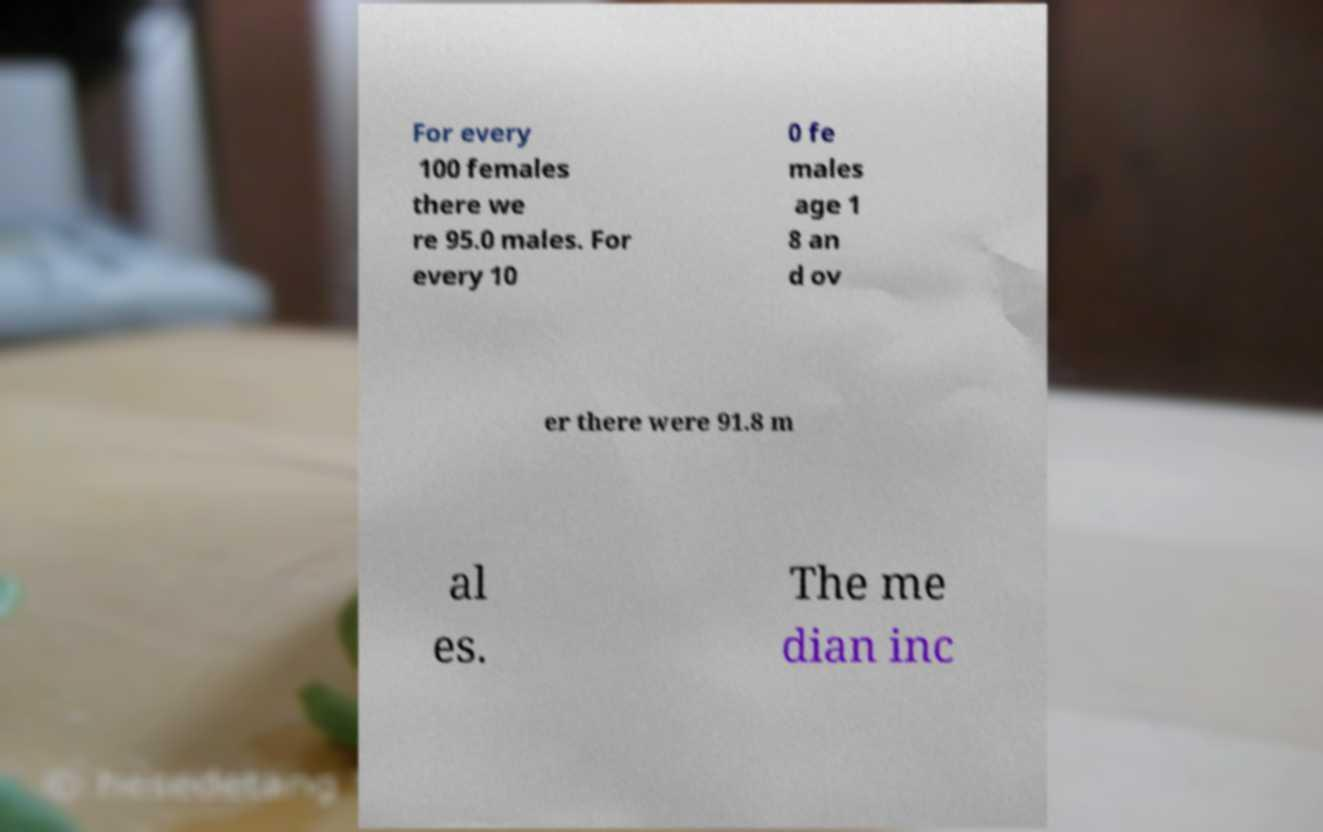For documentation purposes, I need the text within this image transcribed. Could you provide that? For every 100 females there we re 95.0 males. For every 10 0 fe males age 1 8 an d ov er there were 91.8 m al es. The me dian inc 